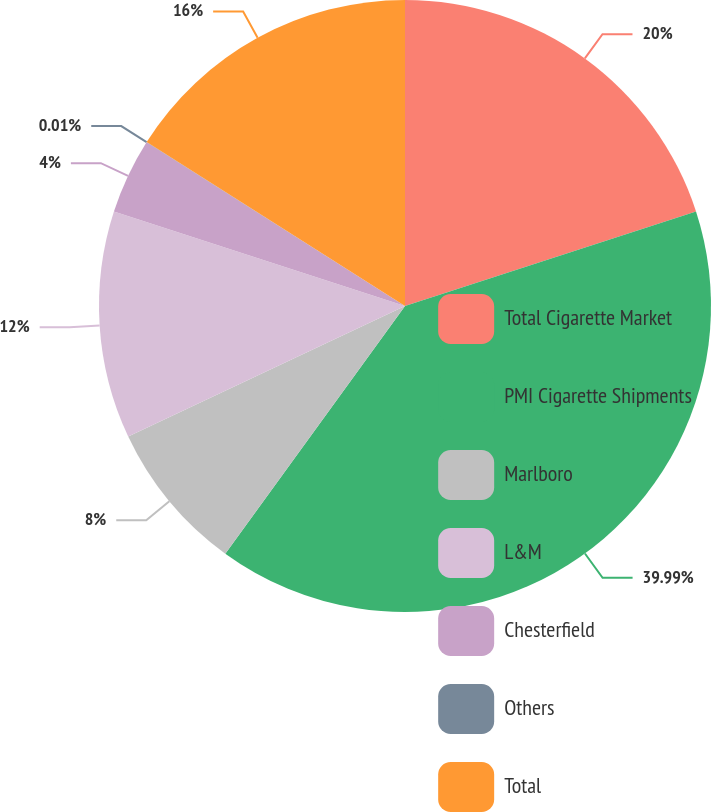Convert chart to OTSL. <chart><loc_0><loc_0><loc_500><loc_500><pie_chart><fcel>Total Cigarette Market<fcel>PMI Cigarette Shipments<fcel>Marlboro<fcel>L&M<fcel>Chesterfield<fcel>Others<fcel>Total<nl><fcel>20.0%<fcel>39.99%<fcel>8.0%<fcel>12.0%<fcel>4.0%<fcel>0.01%<fcel>16.0%<nl></chart> 